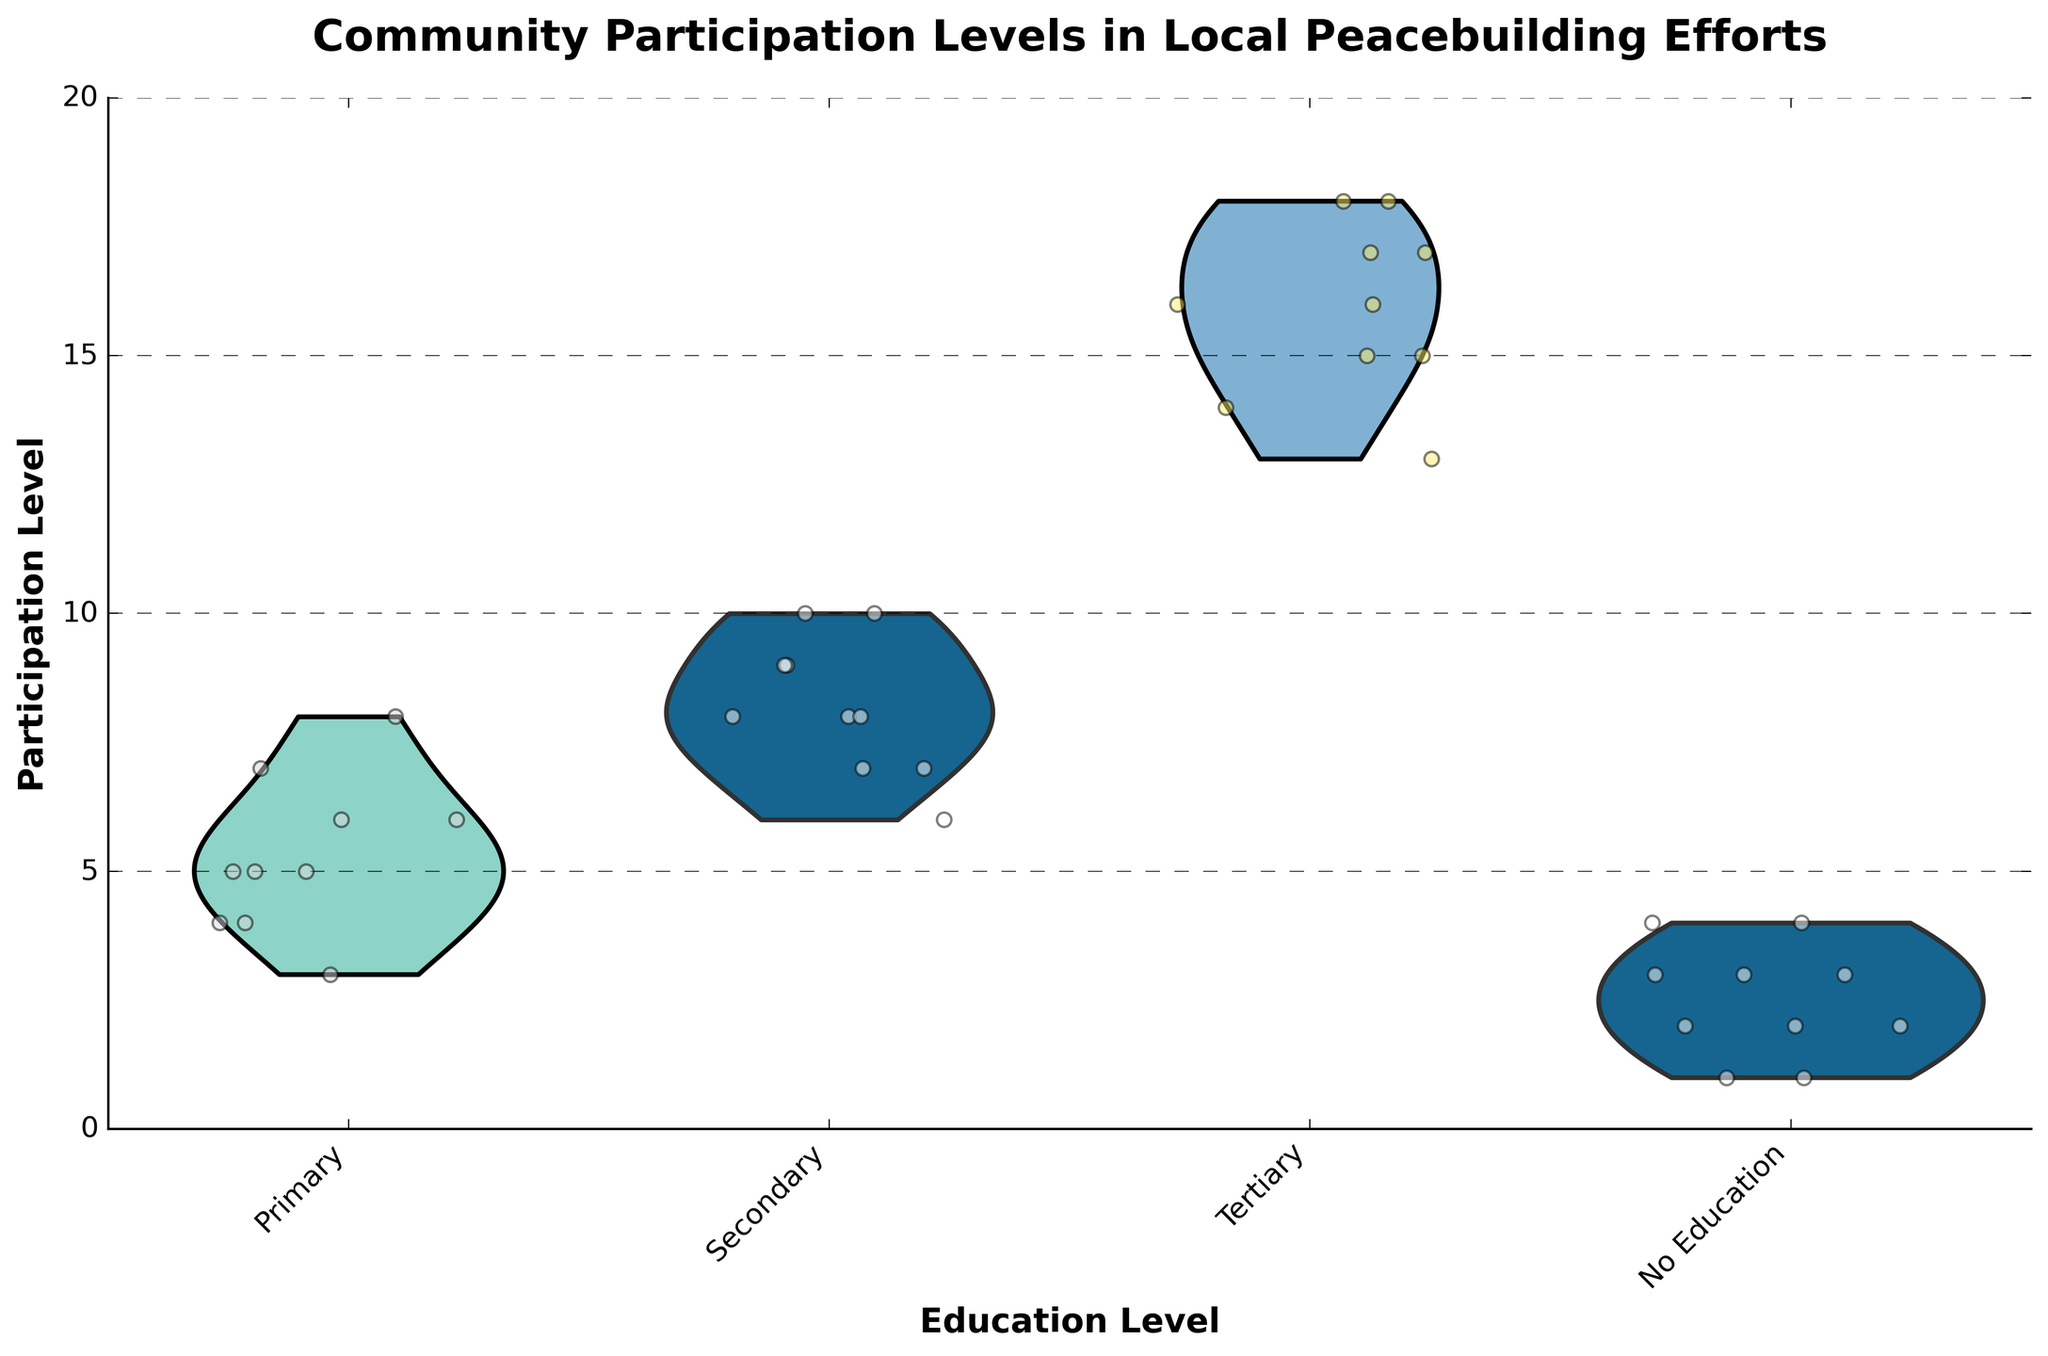How many different education levels are shown in the plot? The x-axis in the plot lists the different education levels. Count the unique labels to determine the number of education levels.
Answer: 4 What is the title of the plot? The title of the plot is prominently displayed at the top.
Answer: Community Participation Levels in Local Peacebuilding Efforts Which education level shows the highest individual participation level? Look at the y-axis (Participation Level) for each education level and identify the highest value.
Answer: Tertiary What is the median participation level for individuals with secondary education? In the secondary education group, arrange the participation levels in ascending order and find the middle value.
Answer: 8 Which education level has the most variability in participation levels? The width of the violin plot indicates the variability. Compare the widths of each group's violin plot.
Answer: Tertiary Between 'No Education' and 'Primary' education levels, which shows a higher median participation level? Compare the central tendency lines (if present) or the overall distribution center for both 'No Education' and 'Primary' levels.
Answer: Primary How do the participation distributions for 'Secondary' and 'Primary' education levels compare? Look at the shapes and spread of the violin plots for both 'Secondary' and 'Primary' levels to compare distributions.
Answer: Secondary has a higher and more varied distribution What can you say about the overall trend in participation levels as education increases? Observe the positions and spreads of the violin plots as you move from 'No Education' to 'Tertiary'.
Answer: Participation levels generally increase with higher education levels What is the range of participation levels for individuals with 'Primary' education? Identify the minimum and maximum participation levels for the 'Primary' group and calculate the difference.
Answer: 3 to 8 Which education level has points that appear more tightly clustered? Look for the education level where the jittered points are closely packed together.
Answer: No Education 